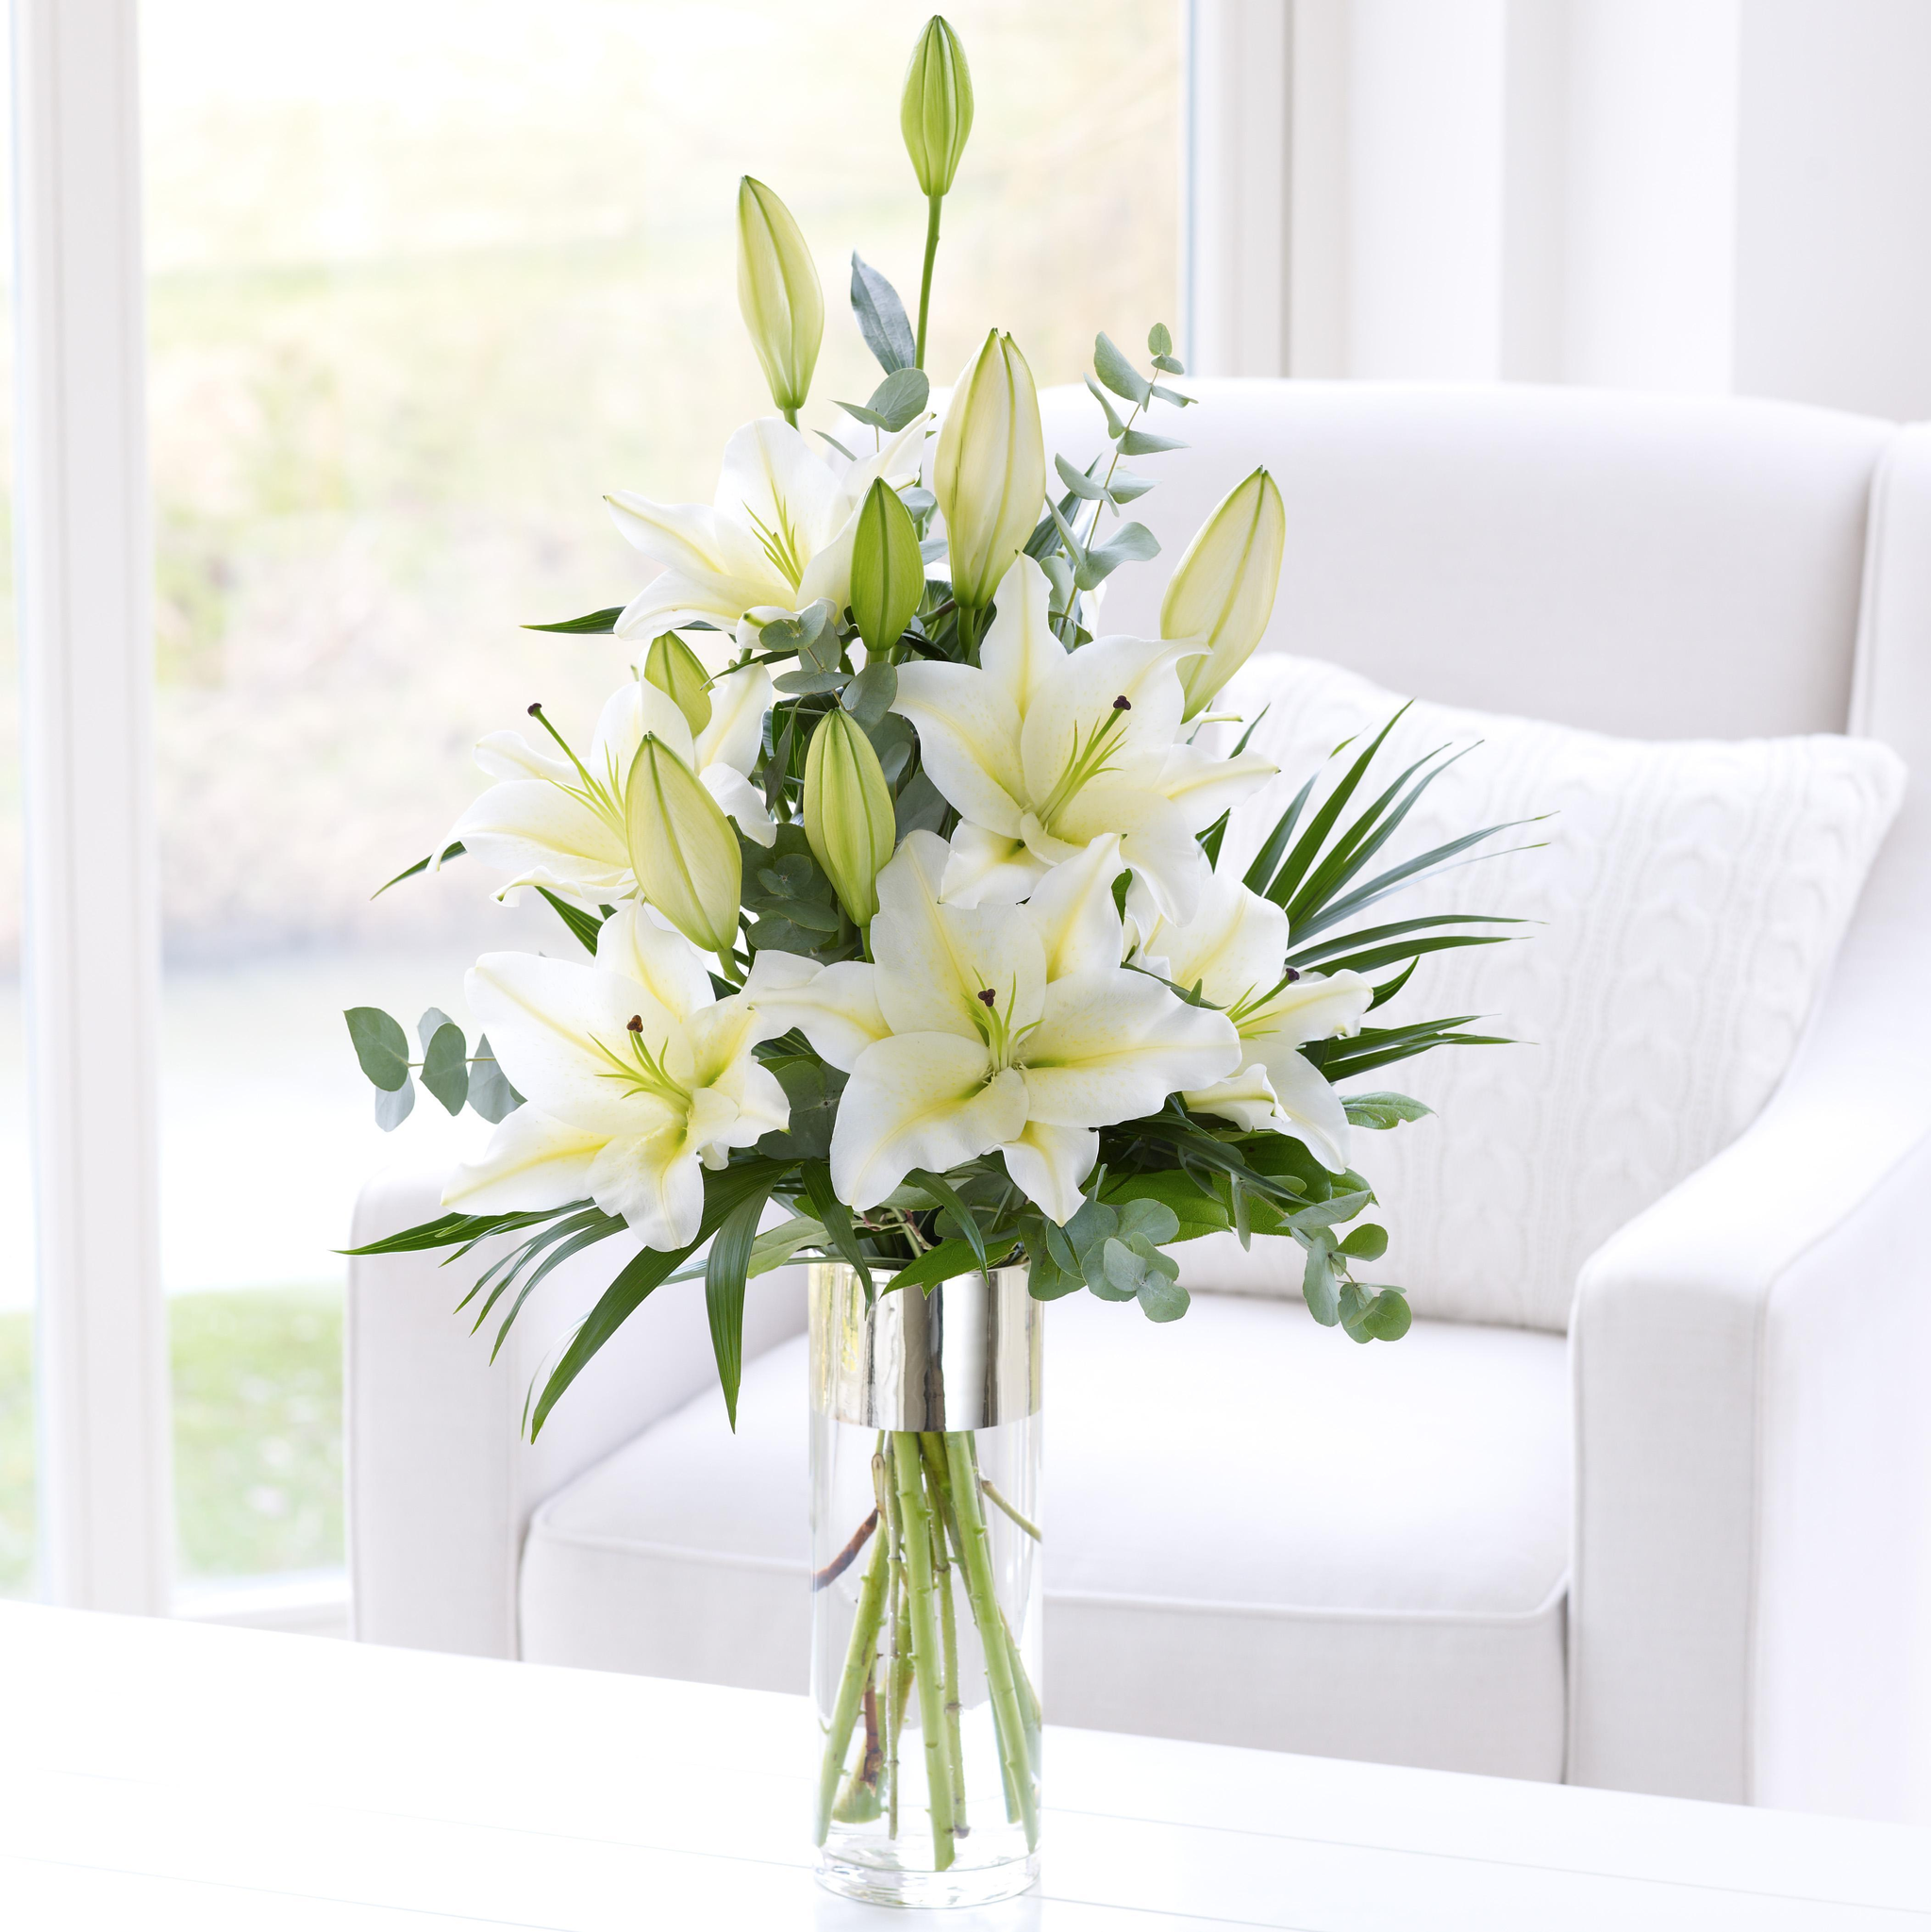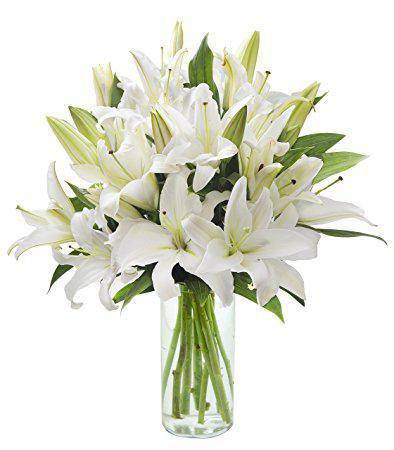The first image is the image on the left, the second image is the image on the right. Considering the images on both sides, is "One arrangement showcases white flowers and the other contains pink flowers." valid? Answer yes or no. No. 